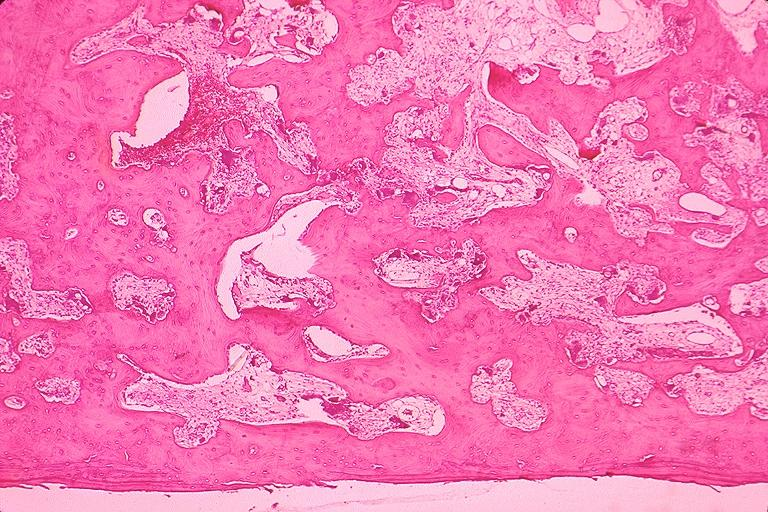what is present?
Answer the question using a single word or phrase. Oral 